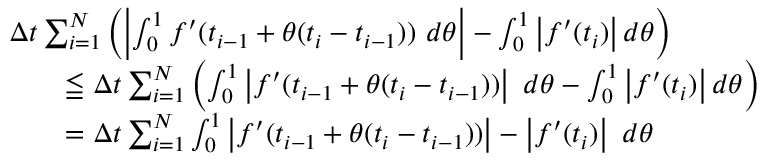Convert formula to latex. <formula><loc_0><loc_0><loc_500><loc_500>{ \begin{array} { r l } & { \Delta t \sum _ { i = 1 } ^ { N } \left ( \left | \int _ { 0 } ^ { 1 } f ^ { \prime } ( t _ { i - 1 } + \theta ( t _ { i } - t _ { i - 1 } ) ) \ d \theta \right | - \int _ { 0 } ^ { 1 } \left | f ^ { \prime } ( t _ { i } ) \right | d \theta \right ) } \\ & { \quad \leqq \Delta t \sum _ { i = 1 } ^ { N } \left ( \int _ { 0 } ^ { 1 } \left | f ^ { \prime } ( t _ { i - 1 } + \theta ( t _ { i } - t _ { i - 1 } ) ) \right | \ d \theta - \int _ { 0 } ^ { 1 } \left | f ^ { \prime } ( t _ { i } ) \right | d \theta \right ) } \\ & { \quad = \Delta t \sum _ { i = 1 } ^ { N } \int _ { 0 } ^ { 1 } \left | f ^ { \prime } ( t _ { i - 1 } + \theta ( t _ { i } - t _ { i - 1 } ) ) \right | - \left | f ^ { \prime } ( t _ { i } ) \right | \ d \theta } \end{array} }</formula> 